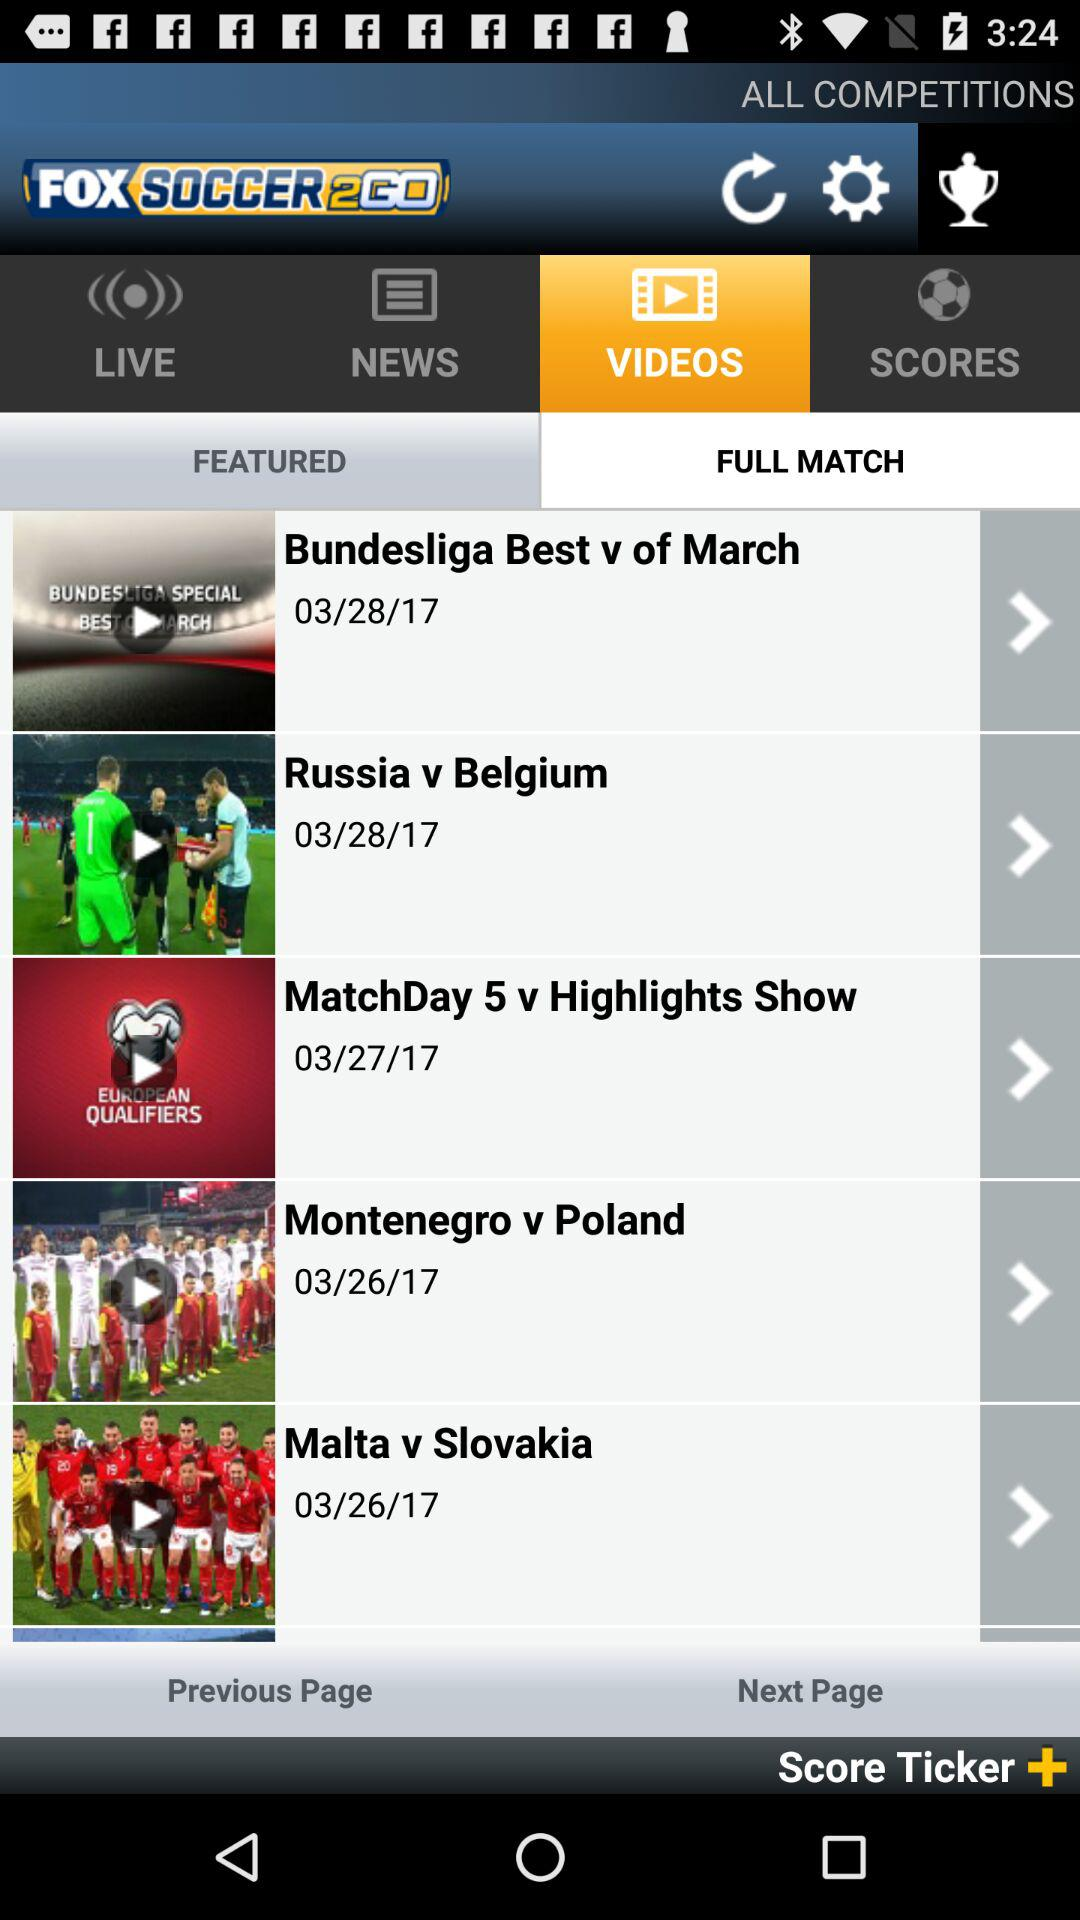Which tab am I on? You are on the tabs "VIDEOS" and "FULL MATCH". 